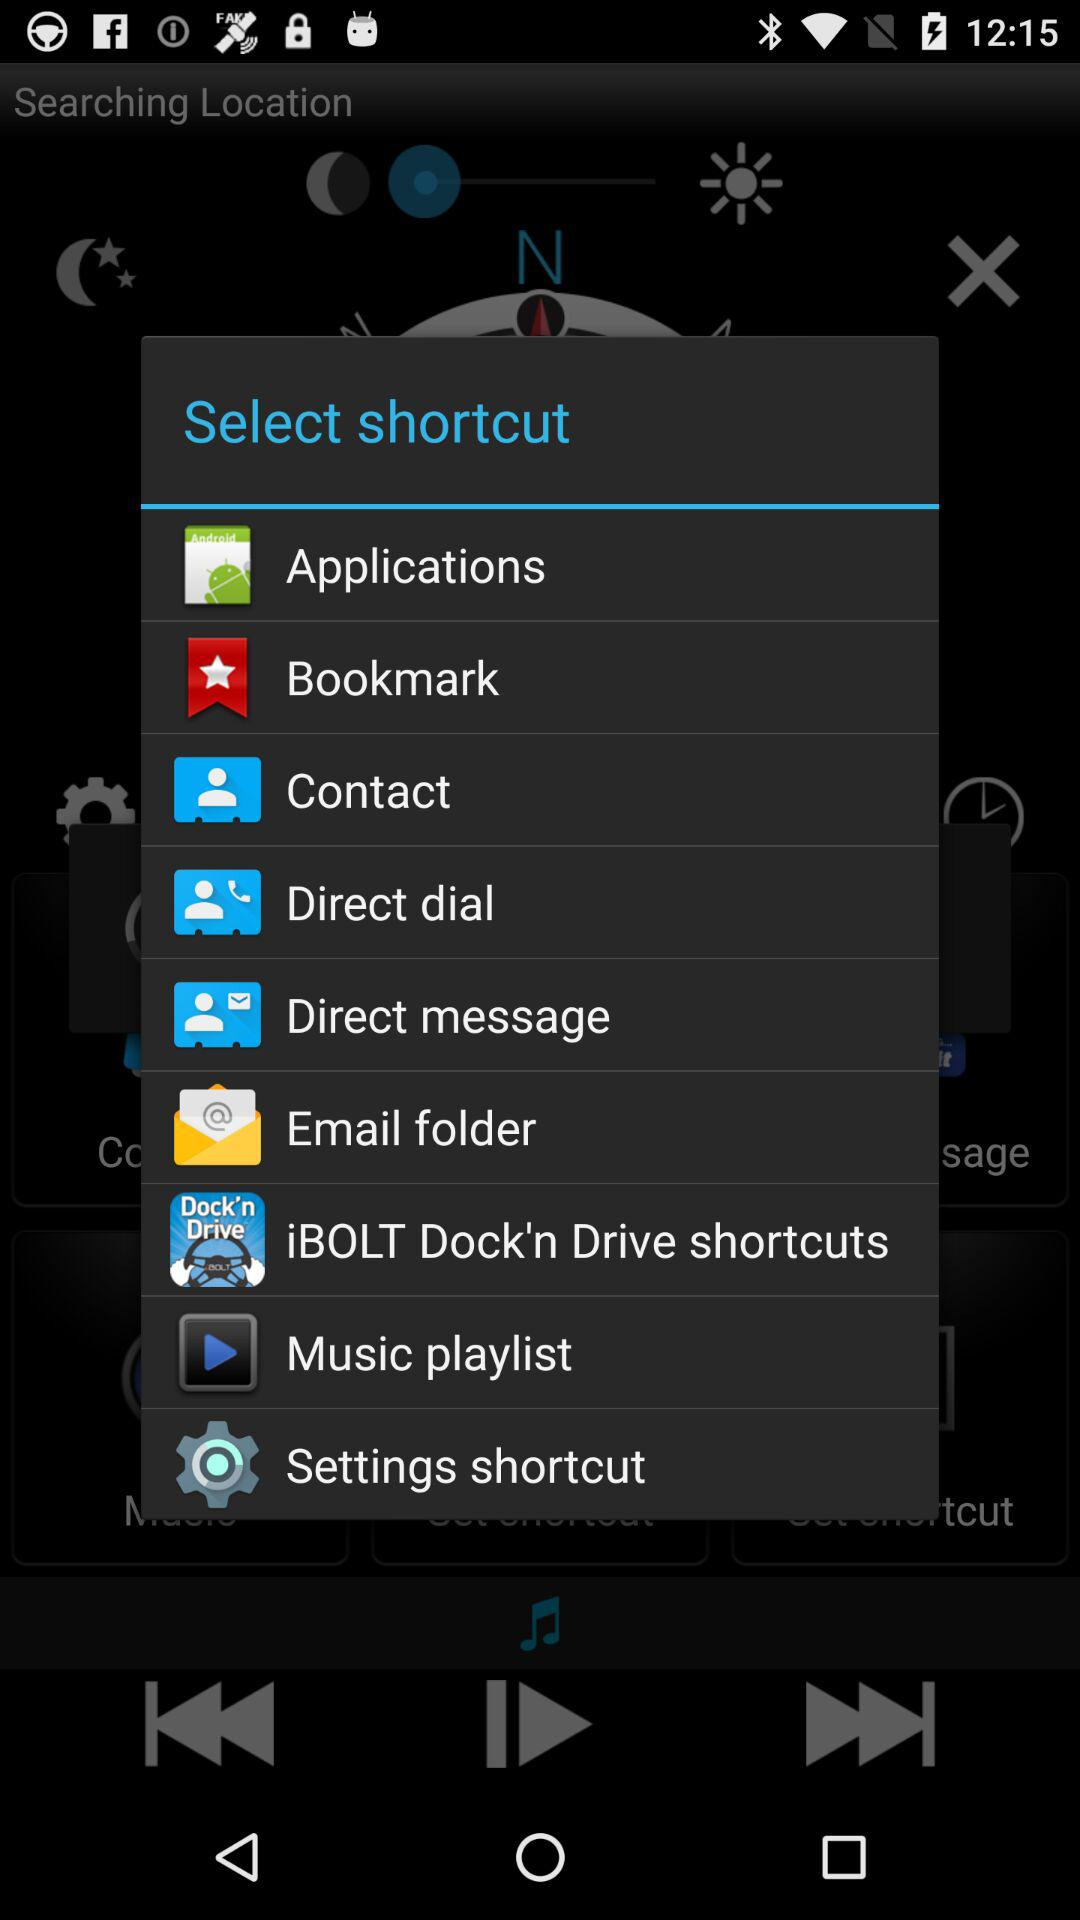Which options can I select as a shortcut? The options that you can select as a shortcut are "Applications", "Bookmark", "Contact", "Direct dial", "Direct message", "Email folder", "iBOLT Dock'n Drive shortcuts", "Music playlist" and "Settings shortcut". 